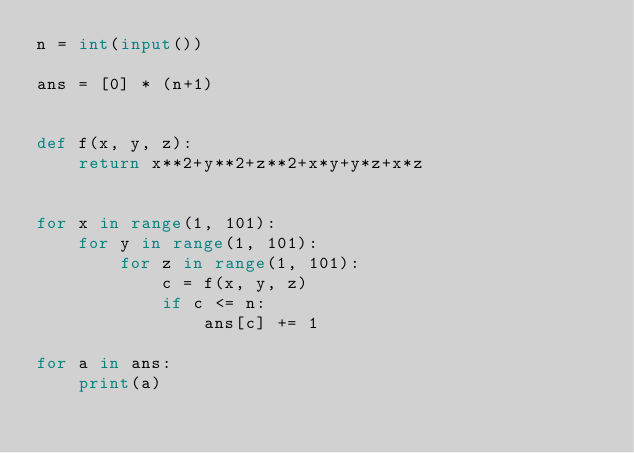<code> <loc_0><loc_0><loc_500><loc_500><_Python_>n = int(input())

ans = [0] * (n+1)


def f(x, y, z):
    return x**2+y**2+z**2+x*y+y*z+x*z


for x in range(1, 101):
    for y in range(1, 101):
        for z in range(1, 101):
            c = f(x, y, z)
            if c <= n:
                ans[c] += 1

for a in ans:
    print(a)
</code> 